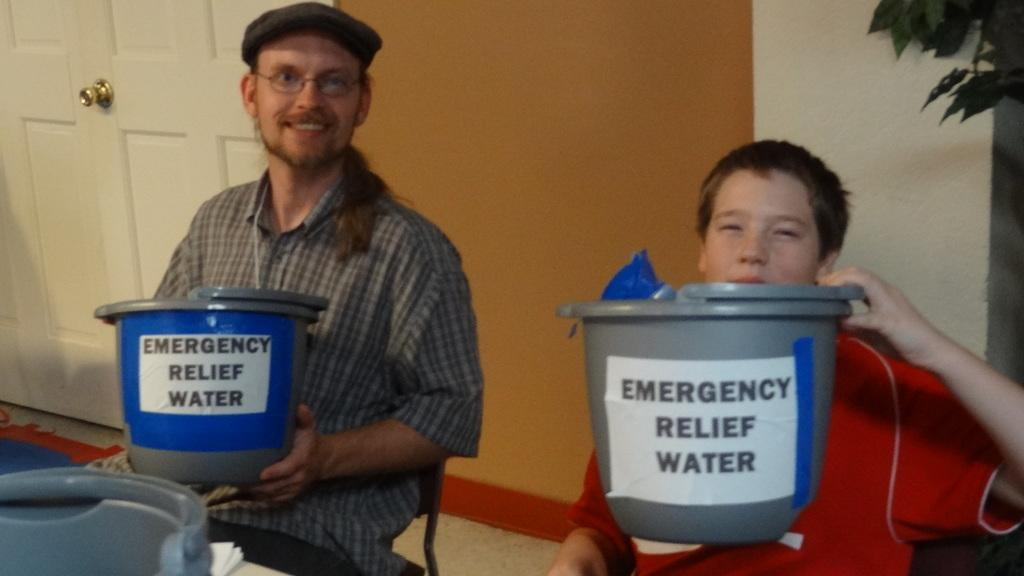<image>
Render a clear and concise summary of the photo. A man and a boy hold up buckets that say emergency relief water. 